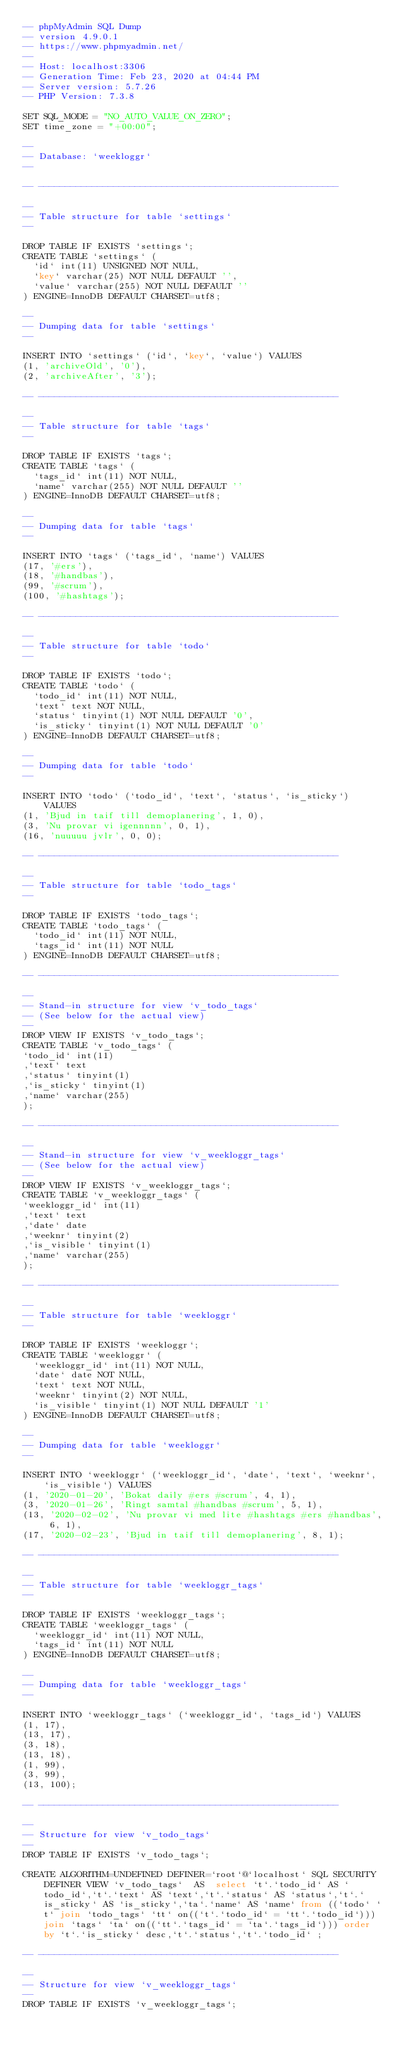Convert code to text. <code><loc_0><loc_0><loc_500><loc_500><_SQL_>-- phpMyAdmin SQL Dump
-- version 4.9.0.1
-- https://www.phpmyadmin.net/
--
-- Host: localhost:3306
-- Generation Time: Feb 23, 2020 at 04:44 PM
-- Server version: 5.7.26
-- PHP Version: 7.3.8

SET SQL_MODE = "NO_AUTO_VALUE_ON_ZERO";
SET time_zone = "+00:00";

--
-- Database: `weekloggr`
--

-- --------------------------------------------------------

--
-- Table structure for table `settings`
--

DROP TABLE IF EXISTS `settings`;
CREATE TABLE `settings` (
  `id` int(11) UNSIGNED NOT NULL,
  `key` varchar(25) NOT NULL DEFAULT '',
  `value` varchar(255) NOT NULL DEFAULT ''
) ENGINE=InnoDB DEFAULT CHARSET=utf8;

--
-- Dumping data for table `settings`
--

INSERT INTO `settings` (`id`, `key`, `value`) VALUES
(1, 'archiveOld', '0'),
(2, 'archiveAfter', '3');

-- --------------------------------------------------------

--
-- Table structure for table `tags`
--

DROP TABLE IF EXISTS `tags`;
CREATE TABLE `tags` (
  `tags_id` int(11) NOT NULL,
  `name` varchar(255) NOT NULL DEFAULT ''
) ENGINE=InnoDB DEFAULT CHARSET=utf8;

--
-- Dumping data for table `tags`
--

INSERT INTO `tags` (`tags_id`, `name`) VALUES
(17, '#ers'),
(18, '#handbas'),
(99, '#scrum'),
(100, '#hashtags');

-- --------------------------------------------------------

--
-- Table structure for table `todo`
--

DROP TABLE IF EXISTS `todo`;
CREATE TABLE `todo` (
  `todo_id` int(11) NOT NULL,
  `text` text NOT NULL,
  `status` tinyint(1) NOT NULL DEFAULT '0',
  `is_sticky` tinyint(1) NOT NULL DEFAULT '0'
) ENGINE=InnoDB DEFAULT CHARSET=utf8;

--
-- Dumping data for table `todo`
--

INSERT INTO `todo` (`todo_id`, `text`, `status`, `is_sticky`) VALUES
(1, 'Bjud in taif till demoplanering', 1, 0),
(3, 'Nu provar vi igennnnn', 0, 1),
(16, 'nuuuuu jvlr', 0, 0);

-- --------------------------------------------------------

--
-- Table structure for table `todo_tags`
--

DROP TABLE IF EXISTS `todo_tags`;
CREATE TABLE `todo_tags` (
  `todo_id` int(11) NOT NULL,
  `tags_id` int(11) NOT NULL
) ENGINE=InnoDB DEFAULT CHARSET=utf8;

-- --------------------------------------------------------

--
-- Stand-in structure for view `v_todo_tags`
-- (See below for the actual view)
--
DROP VIEW IF EXISTS `v_todo_tags`;
CREATE TABLE `v_todo_tags` (
`todo_id` int(11)
,`text` text
,`status` tinyint(1)
,`is_sticky` tinyint(1)
,`name` varchar(255)
);

-- --------------------------------------------------------

--
-- Stand-in structure for view `v_weekloggr_tags`
-- (See below for the actual view)
--
DROP VIEW IF EXISTS `v_weekloggr_tags`;
CREATE TABLE `v_weekloggr_tags` (
`weekloggr_id` int(11)
,`text` text
,`date` date
,`weeknr` tinyint(2)
,`is_visible` tinyint(1)
,`name` varchar(255)
);

-- --------------------------------------------------------

--
-- Table structure for table `weekloggr`
--

DROP TABLE IF EXISTS `weekloggr`;
CREATE TABLE `weekloggr` (
  `weekloggr_id` int(11) NOT NULL,
  `date` date NOT NULL,
  `text` text NOT NULL,
  `weeknr` tinyint(2) NOT NULL,
  `is_visible` tinyint(1) NOT NULL DEFAULT '1'
) ENGINE=InnoDB DEFAULT CHARSET=utf8;

--
-- Dumping data for table `weekloggr`
--

INSERT INTO `weekloggr` (`weekloggr_id`, `date`, `text`, `weeknr`, `is_visible`) VALUES
(1, '2020-01-20', 'Bokat daily #ers #scrum', 4, 1),
(3, '2020-01-26', 'Ringt samtal #handbas #scrum', 5, 1),
(13, '2020-02-02', 'Nu provar vi med lite #hashtags #ers #handbas', 6, 1),
(17, '2020-02-23', 'Bjud in taif till demoplanering', 8, 1);

-- --------------------------------------------------------

--
-- Table structure for table `weekloggr_tags`
--

DROP TABLE IF EXISTS `weekloggr_tags`;
CREATE TABLE `weekloggr_tags` (
  `weekloggr_id` int(11) NOT NULL,
  `tags_id` int(11) NOT NULL
) ENGINE=InnoDB DEFAULT CHARSET=utf8;

--
-- Dumping data for table `weekloggr_tags`
--

INSERT INTO `weekloggr_tags` (`weekloggr_id`, `tags_id`) VALUES
(1, 17),
(13, 17),
(3, 18),
(13, 18),
(1, 99),
(3, 99),
(13, 100);

-- --------------------------------------------------------

--
-- Structure for view `v_todo_tags`
--
DROP TABLE IF EXISTS `v_todo_tags`;

CREATE ALGORITHM=UNDEFINED DEFINER=`root`@`localhost` SQL SECURITY DEFINER VIEW `v_todo_tags`  AS  select `t`.`todo_id` AS `todo_id`,`t`.`text` AS `text`,`t`.`status` AS `status`,`t`.`is_sticky` AS `is_sticky`,`ta`.`name` AS `name` from ((`todo` `t` join `todo_tags` `tt` on((`t`.`todo_id` = `tt`.`todo_id`))) join `tags` `ta` on((`tt`.`tags_id` = `ta`.`tags_id`))) order by `t`.`is_sticky` desc,`t`.`status`,`t`.`todo_id` ;

-- --------------------------------------------------------

--
-- Structure for view `v_weekloggr_tags`
--
DROP TABLE IF EXISTS `v_weekloggr_tags`;
</code> 